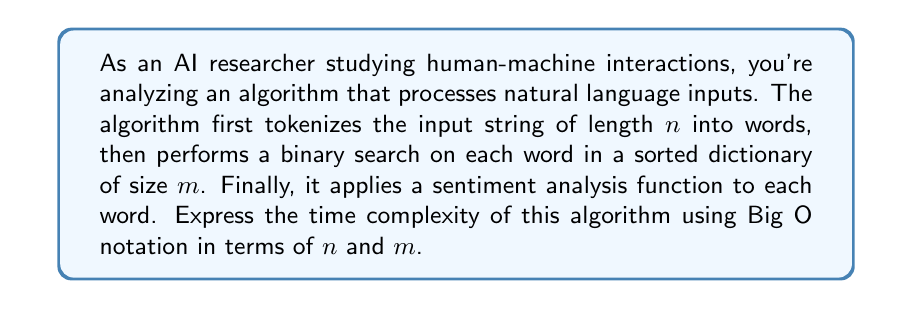What is the answer to this math problem? Let's break down the algorithm and analyze each step:

1. Tokenization:
   - Splitting a string of length $n$ into words typically requires $O(n)$ time.

2. Binary search for each word:
   - There are at most $n$ words (in the case where each character is a word).
   - Binary search on a sorted dictionary of size $m$ takes $O(\log m)$ time.
   - For $n$ words: $O(n \log m)$

3. Sentiment analysis for each word:
   - Assuming the sentiment analysis function takes constant time for each word.
   - For $n$ words: $O(n)$

Now, let's combine these steps:

$$O(n) + O(n \log m) + O(n)$$

The $O(n)$ terms can be combined:

$$O(n) + O(n \log m)$$

In Big O notation, we keep the term with the highest growth rate. Since $\log m$ is always positive for $m > 1$, $n \log m$ grows faster than $n$. Therefore, we can simplify to:

$$O(n \log m)$$

This represents the overall time complexity of the algorithm.
Answer: $O(n \log m)$ 